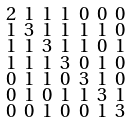<formula> <loc_0><loc_0><loc_500><loc_500>\begin{smallmatrix} 2 & 1 & 1 & 1 & 0 & 0 & 0 \\ 1 & 3 & 1 & 1 & 1 & 1 & 0 \\ 1 & 1 & 3 & 1 & 1 & 0 & 1 \\ 1 & 1 & 1 & 3 & 0 & 1 & 0 \\ 0 & 1 & 1 & 0 & 3 & 1 & 0 \\ 0 & 1 & 0 & 1 & 1 & 3 & 1 \\ 0 & 0 & 1 & 0 & 0 & 1 & 3 \end{smallmatrix}</formula> 